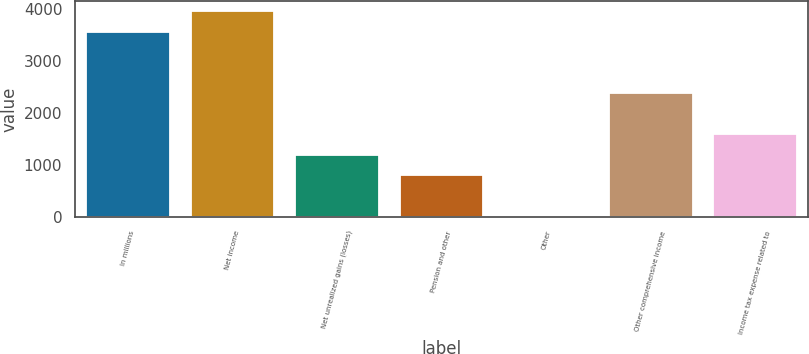Convert chart. <chart><loc_0><loc_0><loc_500><loc_500><bar_chart><fcel>In millions<fcel>Net income<fcel>Net unrealized gains (losses)<fcel>Pension and other<fcel>Other<fcel>Other comprehensive income<fcel>Income tax expense related to<nl><fcel>3557.8<fcel>3952<fcel>1192.6<fcel>798.4<fcel>10<fcel>2375.2<fcel>1586.8<nl></chart> 